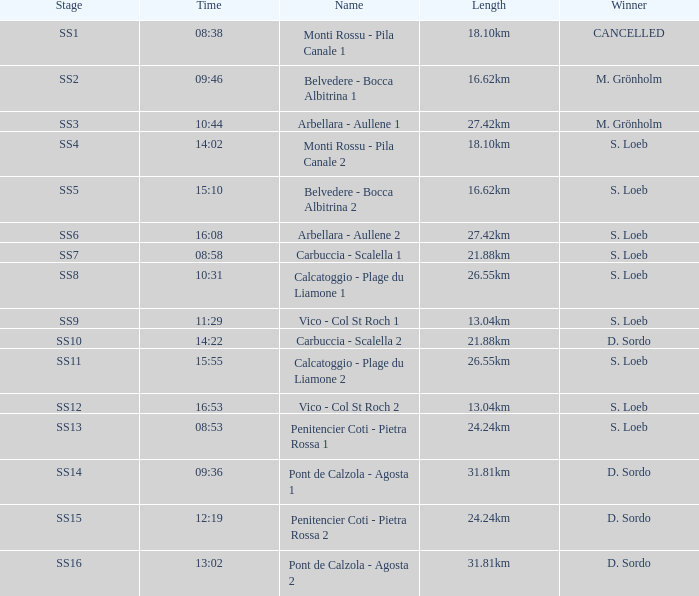What is the title of the ss5 stage? Belvedere - Bocca Albitrina 2. 